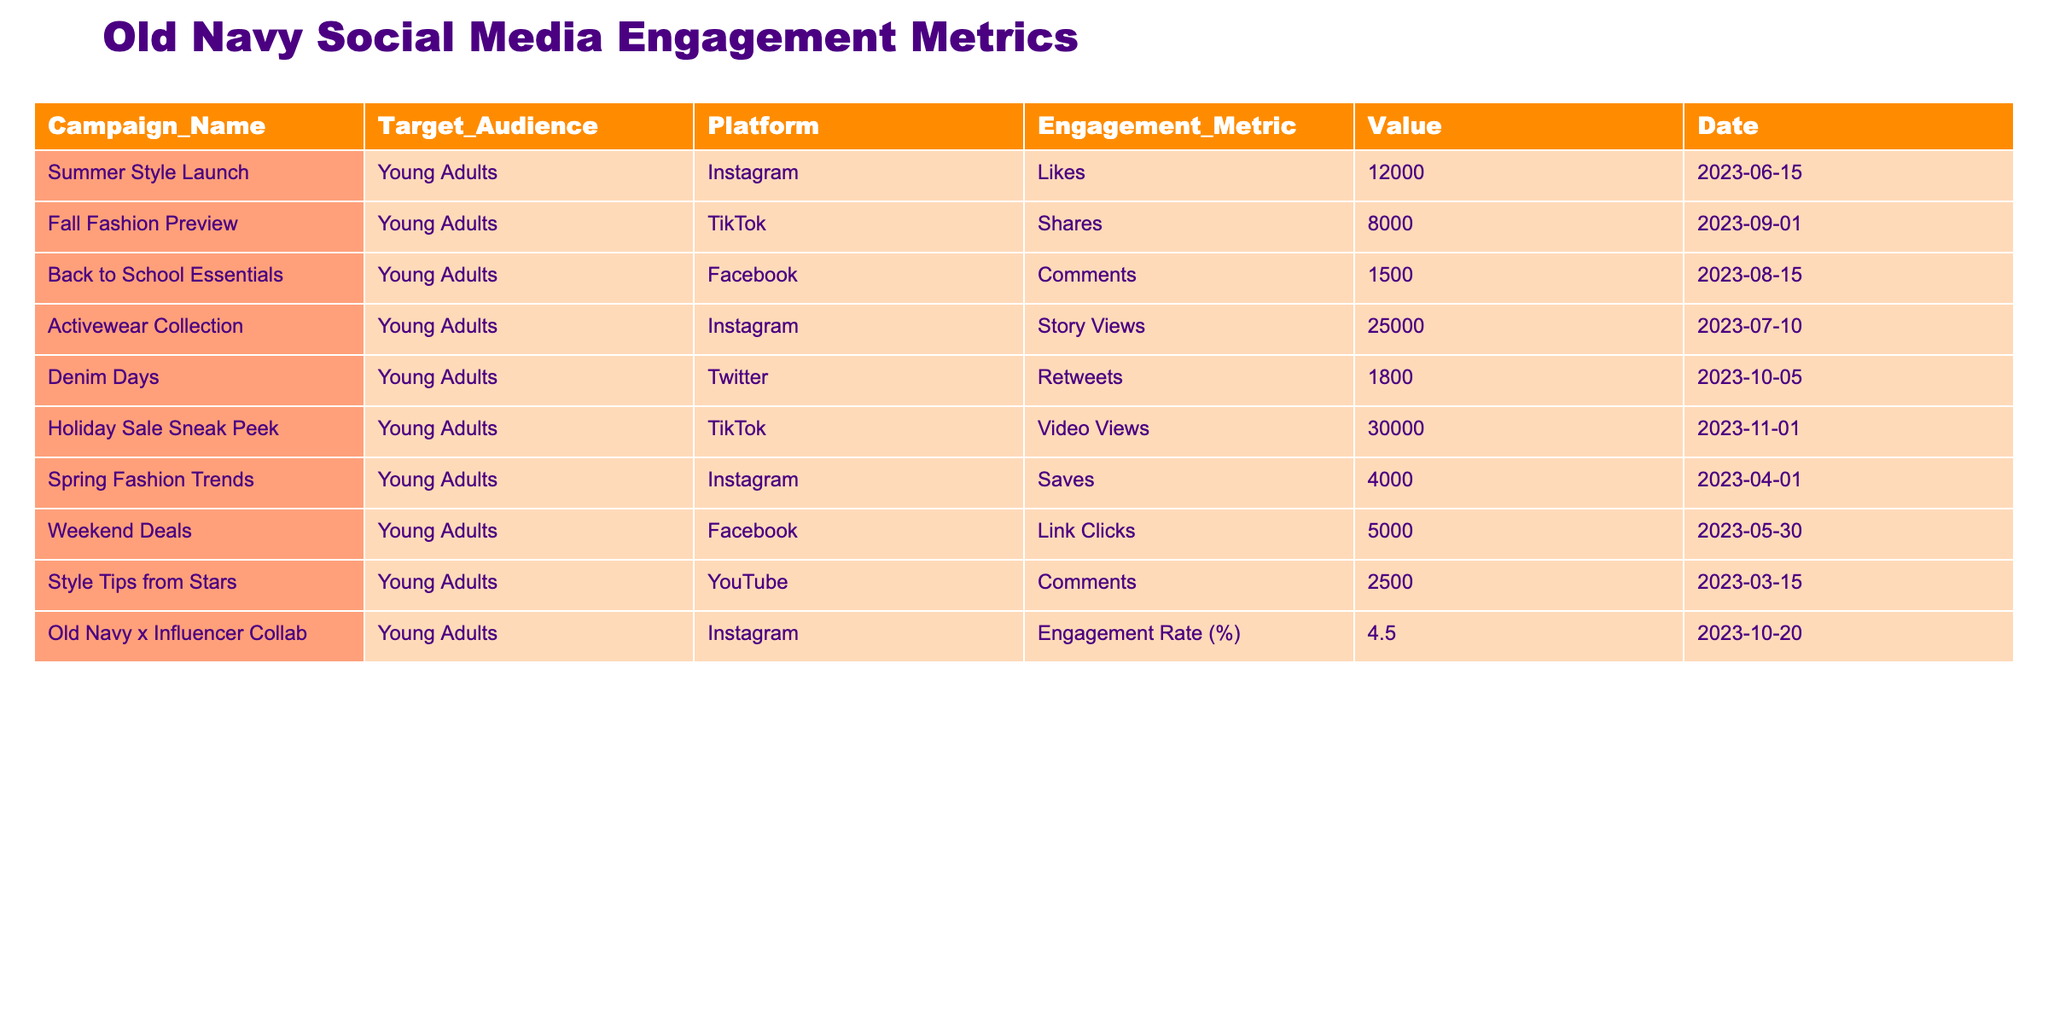What was the engagement metric with the highest value in the table? The table shows various engagement metrics for different campaigns. By examining the "Value" column, it is clear that the maximum value is 30000 from the "Holiday Sale Sneak Peek" campaign measured in "Video Views".
Answer: 30000 How many total likes were recorded across all campaigns on Instagram? From the table, there are two campaigns on Instagram that have likes: "Summer Style Launch" with 12000 likes and "Old Navy x Influencer Collab" measured with an engagement rate, not likes. So, we only count the likes from "Summer Style Launch". This gives us a total of 12000 likes as there are no other Instagram campaigns with likes recorded.
Answer: 12000 Which campaign received the highest engagement on TikTok? According to the table, the two TikTok campaigns are "Fall Fashion Preview" with 8000 shares and "Holiday Sale Sneak Peek" with 30000 video views. Since video views are generally a broader measure of engagement than shares, "Holiday Sale Sneak Peek" is determined to have the highest engagement on TikTok.
Answer: Holiday Sale Sneak Peek What is the average number of comments from the campaigns listed? The only campaigns with comments recorded are "Back to School Essentials" with 1500 comments and "Style Tips from Stars" with 2500 comments. To find the average, we sum 1500 and 2500 to get 4000 and then divide by the number of campaigns (2). So, the average is 4000/2 = 2000.
Answer: 2000 Is the engagement rate for the "Old Navy x Influencer Collab" campaign above 5%? The engagement rate for "Old Navy x Influencer Collab" is stated as 4.5%. Since 4.5% is less than 5%, the answer to whether it is above 5% is no.
Answer: No Which social media platform had the most significant single engagement value? By analyzing the "Value" column, the maximum engagement value of 30000 belongs to the "Holiday Sale Sneak Peek" campaign on TikTok, which indicates that TikTok had the most significant single engagement value recorded in the table.
Answer: TikTok How many more shares than retweets did the campaigns achieve? From the table, "Fall Fashion Preview" had 8000 shares, and "Denim Days" had 1800 retweets. To determine the difference, we subtract the retweets from the shares, which gives us 8000 - 1800 = 6200 more shares than retweets.
Answer: 6200 Was Instagram the platform with the highest number of engagements in the spring? In the spring, there was one campaign, "Spring Fashion Trends" on Instagram with 4000 saves. Comparing this to the other spring campaigns, Instagram did not have a campaign with a higher recorded engagement than TikTok's "Holiday Sale Sneak Peek" with 30000 views that fall outside of spring, thus it can be concluded that despite existing campaigns, the engagement comparisons do not support Instagram being the highest in spring.
Answer: No 